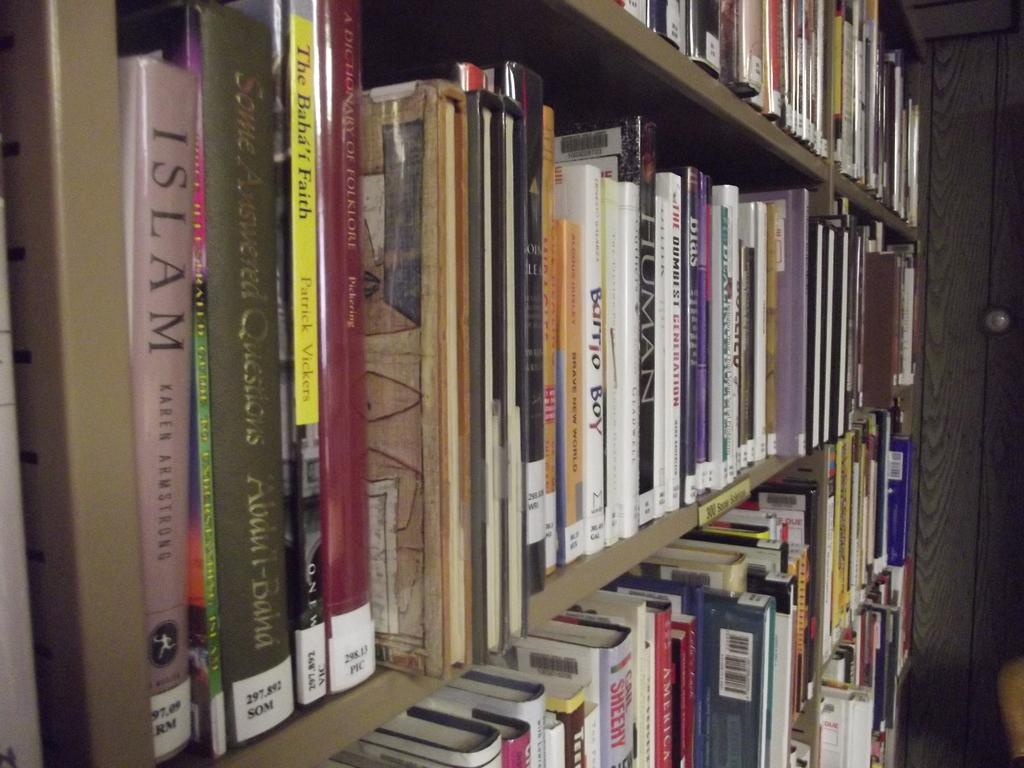<image>
Relay a brief, clear account of the picture shown. Various books, such as Barrio Boy and Islam, sit on a bookshelf. 